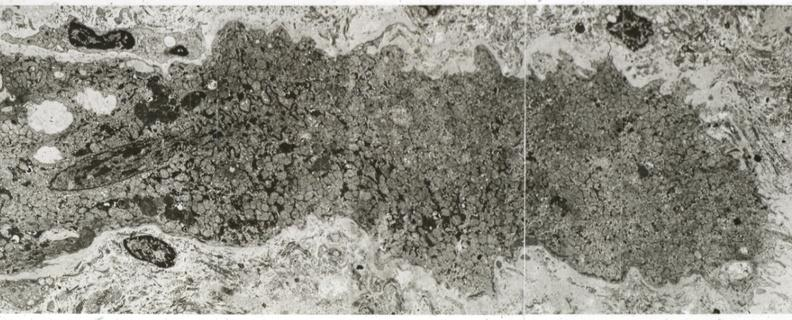what does this image show?
Answer the question using a single word or phrase. Advanced myofiber atrophy 